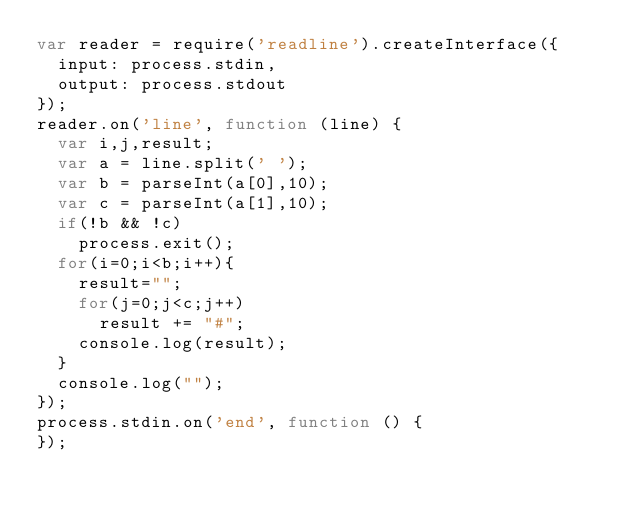<code> <loc_0><loc_0><loc_500><loc_500><_JavaScript_>var reader = require('readline').createInterface({
  input: process.stdin,
  output: process.stdout
});
reader.on('line', function (line) {
  var i,j,result;
  var a = line.split(' ');
  var b = parseInt(a[0],10);
  var c = parseInt(a[1],10);
  if(!b && !c)
    process.exit();
  for(i=0;i<b;i++){
    result="";
    for(j=0;j<c;j++)
      result += "#";
    console.log(result);
  }
  console.log("");
});
process.stdin.on('end', function () {
});
</code> 